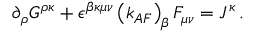Convert formula to latex. <formula><loc_0><loc_0><loc_500><loc_500>\partial _ { \rho } G ^ { \rho \kappa } + \epsilon ^ { \beta \kappa \mu \nu } \left ( k _ { A F } \right ) _ { \beta } F _ { \mu \nu } = J ^ { \kappa } \, .</formula> 